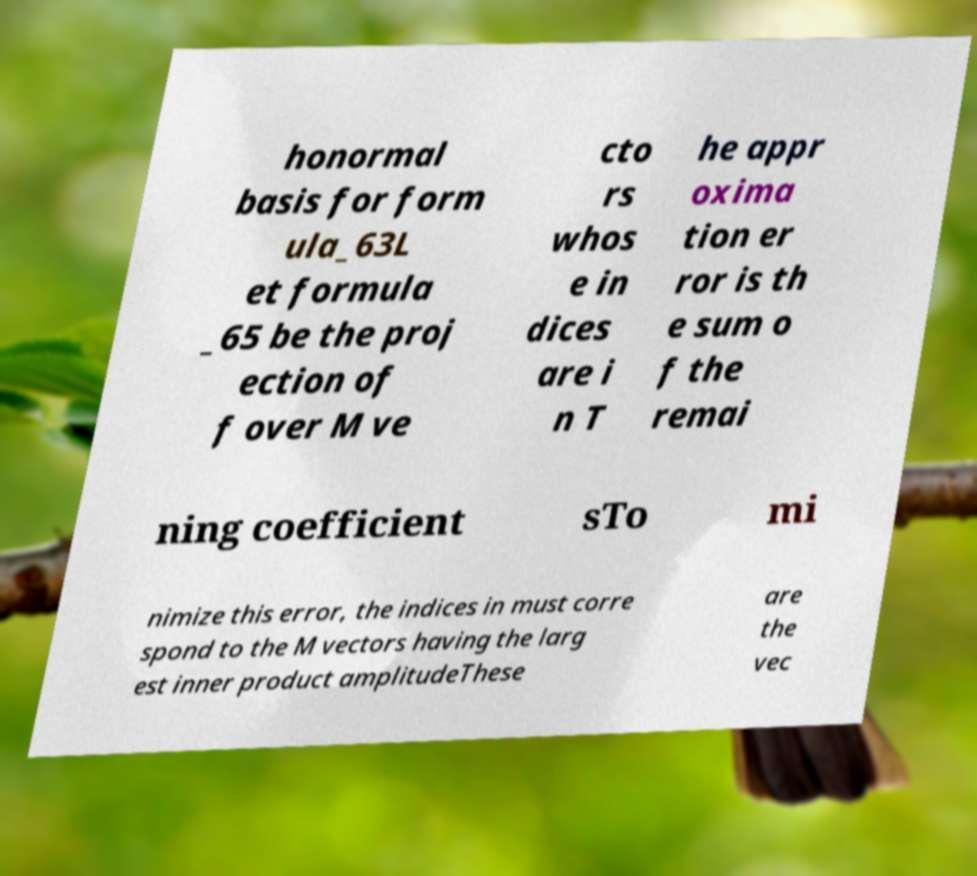Could you assist in decoding the text presented in this image and type it out clearly? honormal basis for form ula_63L et formula _65 be the proj ection of f over M ve cto rs whos e in dices are i n T he appr oxima tion er ror is th e sum o f the remai ning coefficient sTo mi nimize this error, the indices in must corre spond to the M vectors having the larg est inner product amplitudeThese are the vec 